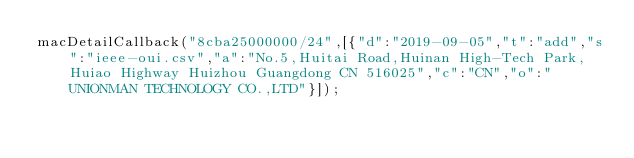Convert code to text. <code><loc_0><loc_0><loc_500><loc_500><_JavaScript_>macDetailCallback("8cba25000000/24",[{"d":"2019-09-05","t":"add","s":"ieee-oui.csv","a":"No.5,Huitai Road,Huinan High-Tech Park,Huiao Highway Huizhou Guangdong CN 516025","c":"CN","o":"UNIONMAN TECHNOLOGY CO.,LTD"}]);
</code> 